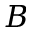<formula> <loc_0><loc_0><loc_500><loc_500>B</formula> 